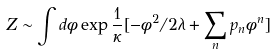<formula> <loc_0><loc_0><loc_500><loc_500>Z \sim \int d \phi \exp { \frac { 1 } { \kappa } [ - \phi ^ { 2 } / 2 \lambda + \sum _ { n } p _ { n } \phi ^ { n } ] }</formula> 